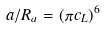<formula> <loc_0><loc_0><loc_500><loc_500>a / R _ { a } = ( \pi c _ { L } ) ^ { 6 }</formula> 